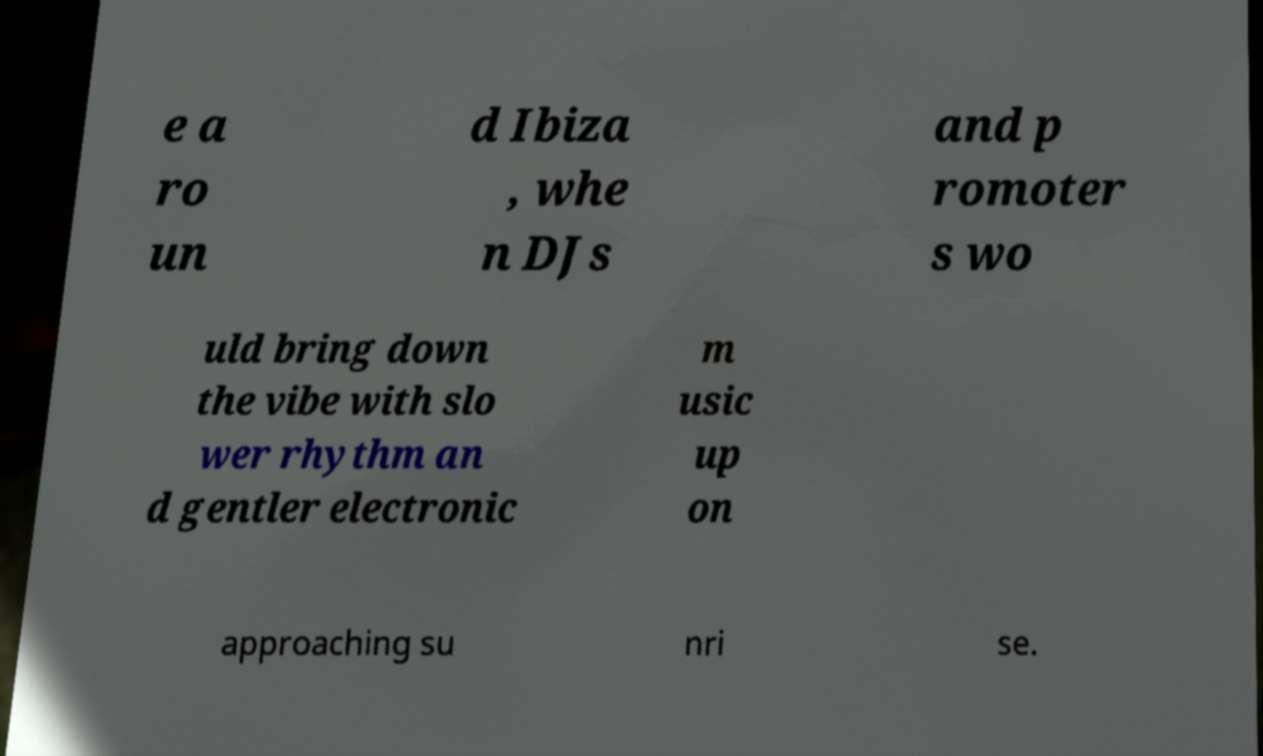Please identify and transcribe the text found in this image. e a ro un d Ibiza , whe n DJs and p romoter s wo uld bring down the vibe with slo wer rhythm an d gentler electronic m usic up on approaching su nri se. 